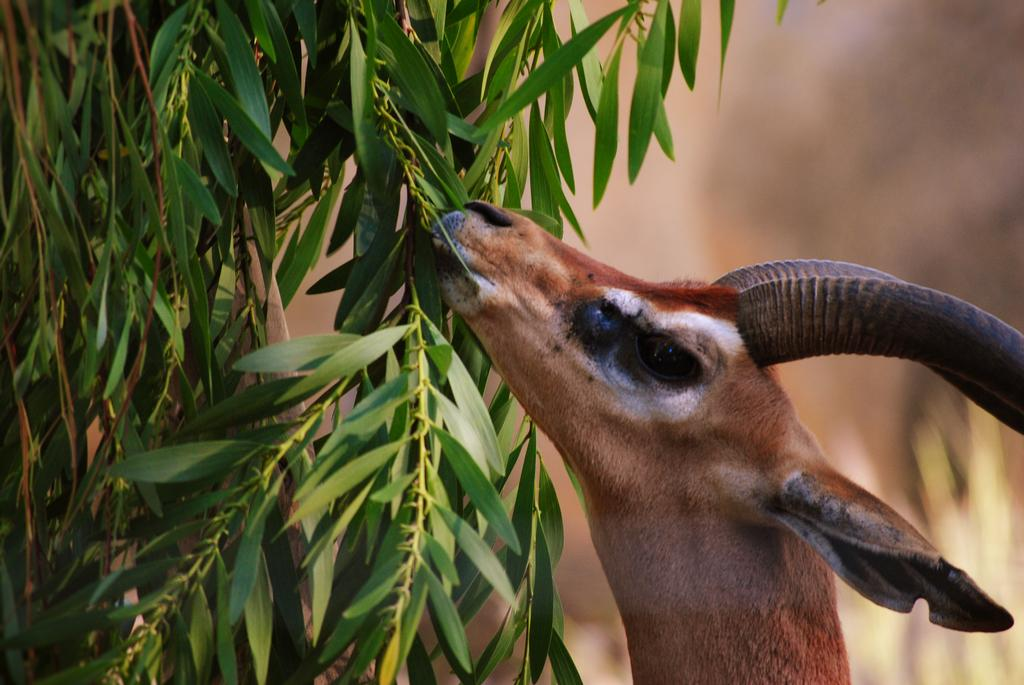What animal can be seen in the image? There is an impala in the image. What is the impala doing in the image? The impala is grazing leaves. What type of vegetation is visible on the left side of the image? There are trees on the left side of the image. What is the color of the background in the image? The background of the image is brown in color. How would you describe the quality of the image's background? The image is blurred in the background. How many kittens are playing with the impala in the image? There are no kittens present in the image; it features an impala grazing leaves. Can you see a ghost in the background of the image? There is no ghost visible in the image; the background is blurred but does not show any ghostly figures. 